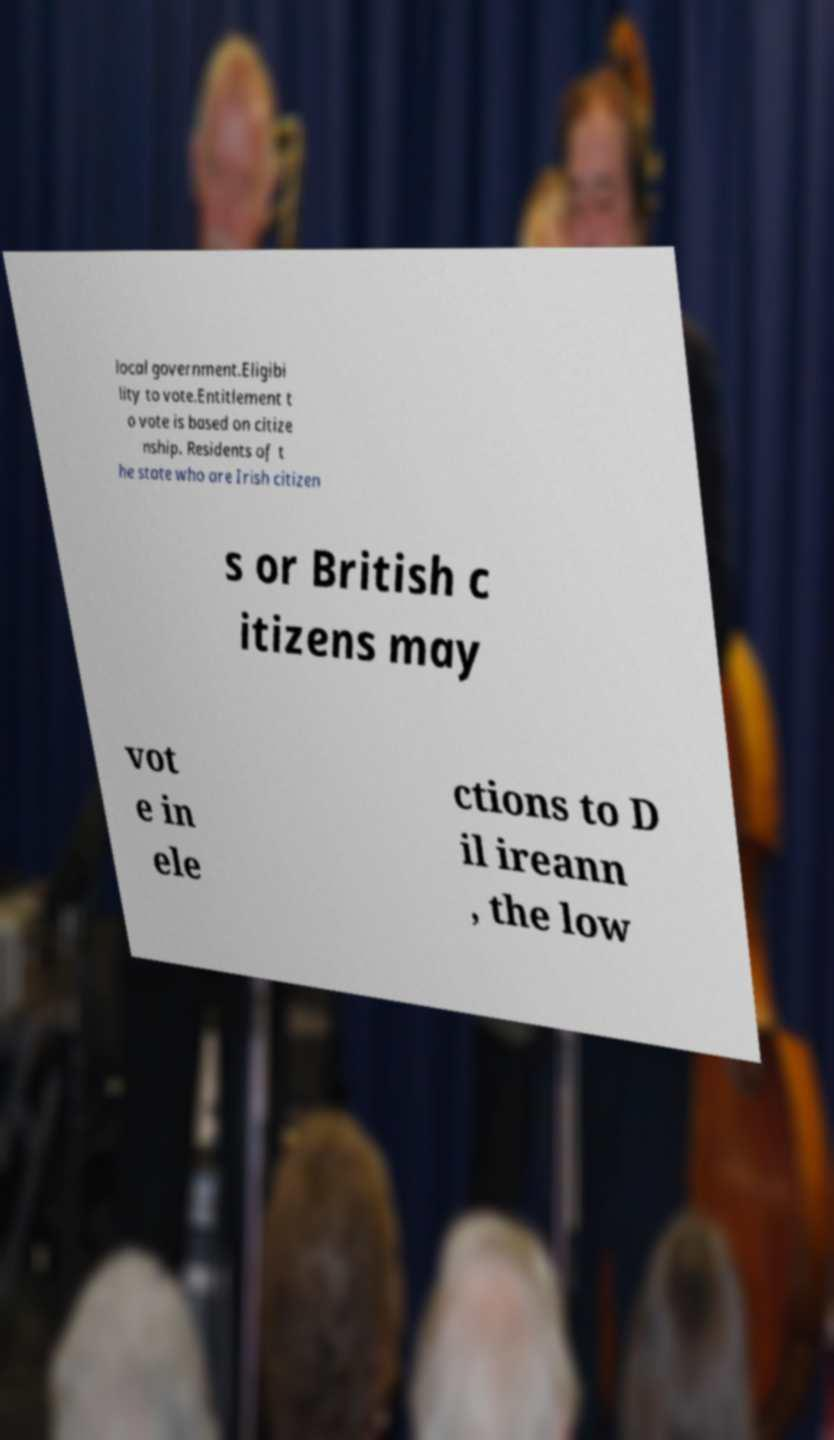What messages or text are displayed in this image? I need them in a readable, typed format. local government.Eligibi lity to vote.Entitlement t o vote is based on citize nship. Residents of t he state who are Irish citizen s or British c itizens may vot e in ele ctions to D il ireann , the low 